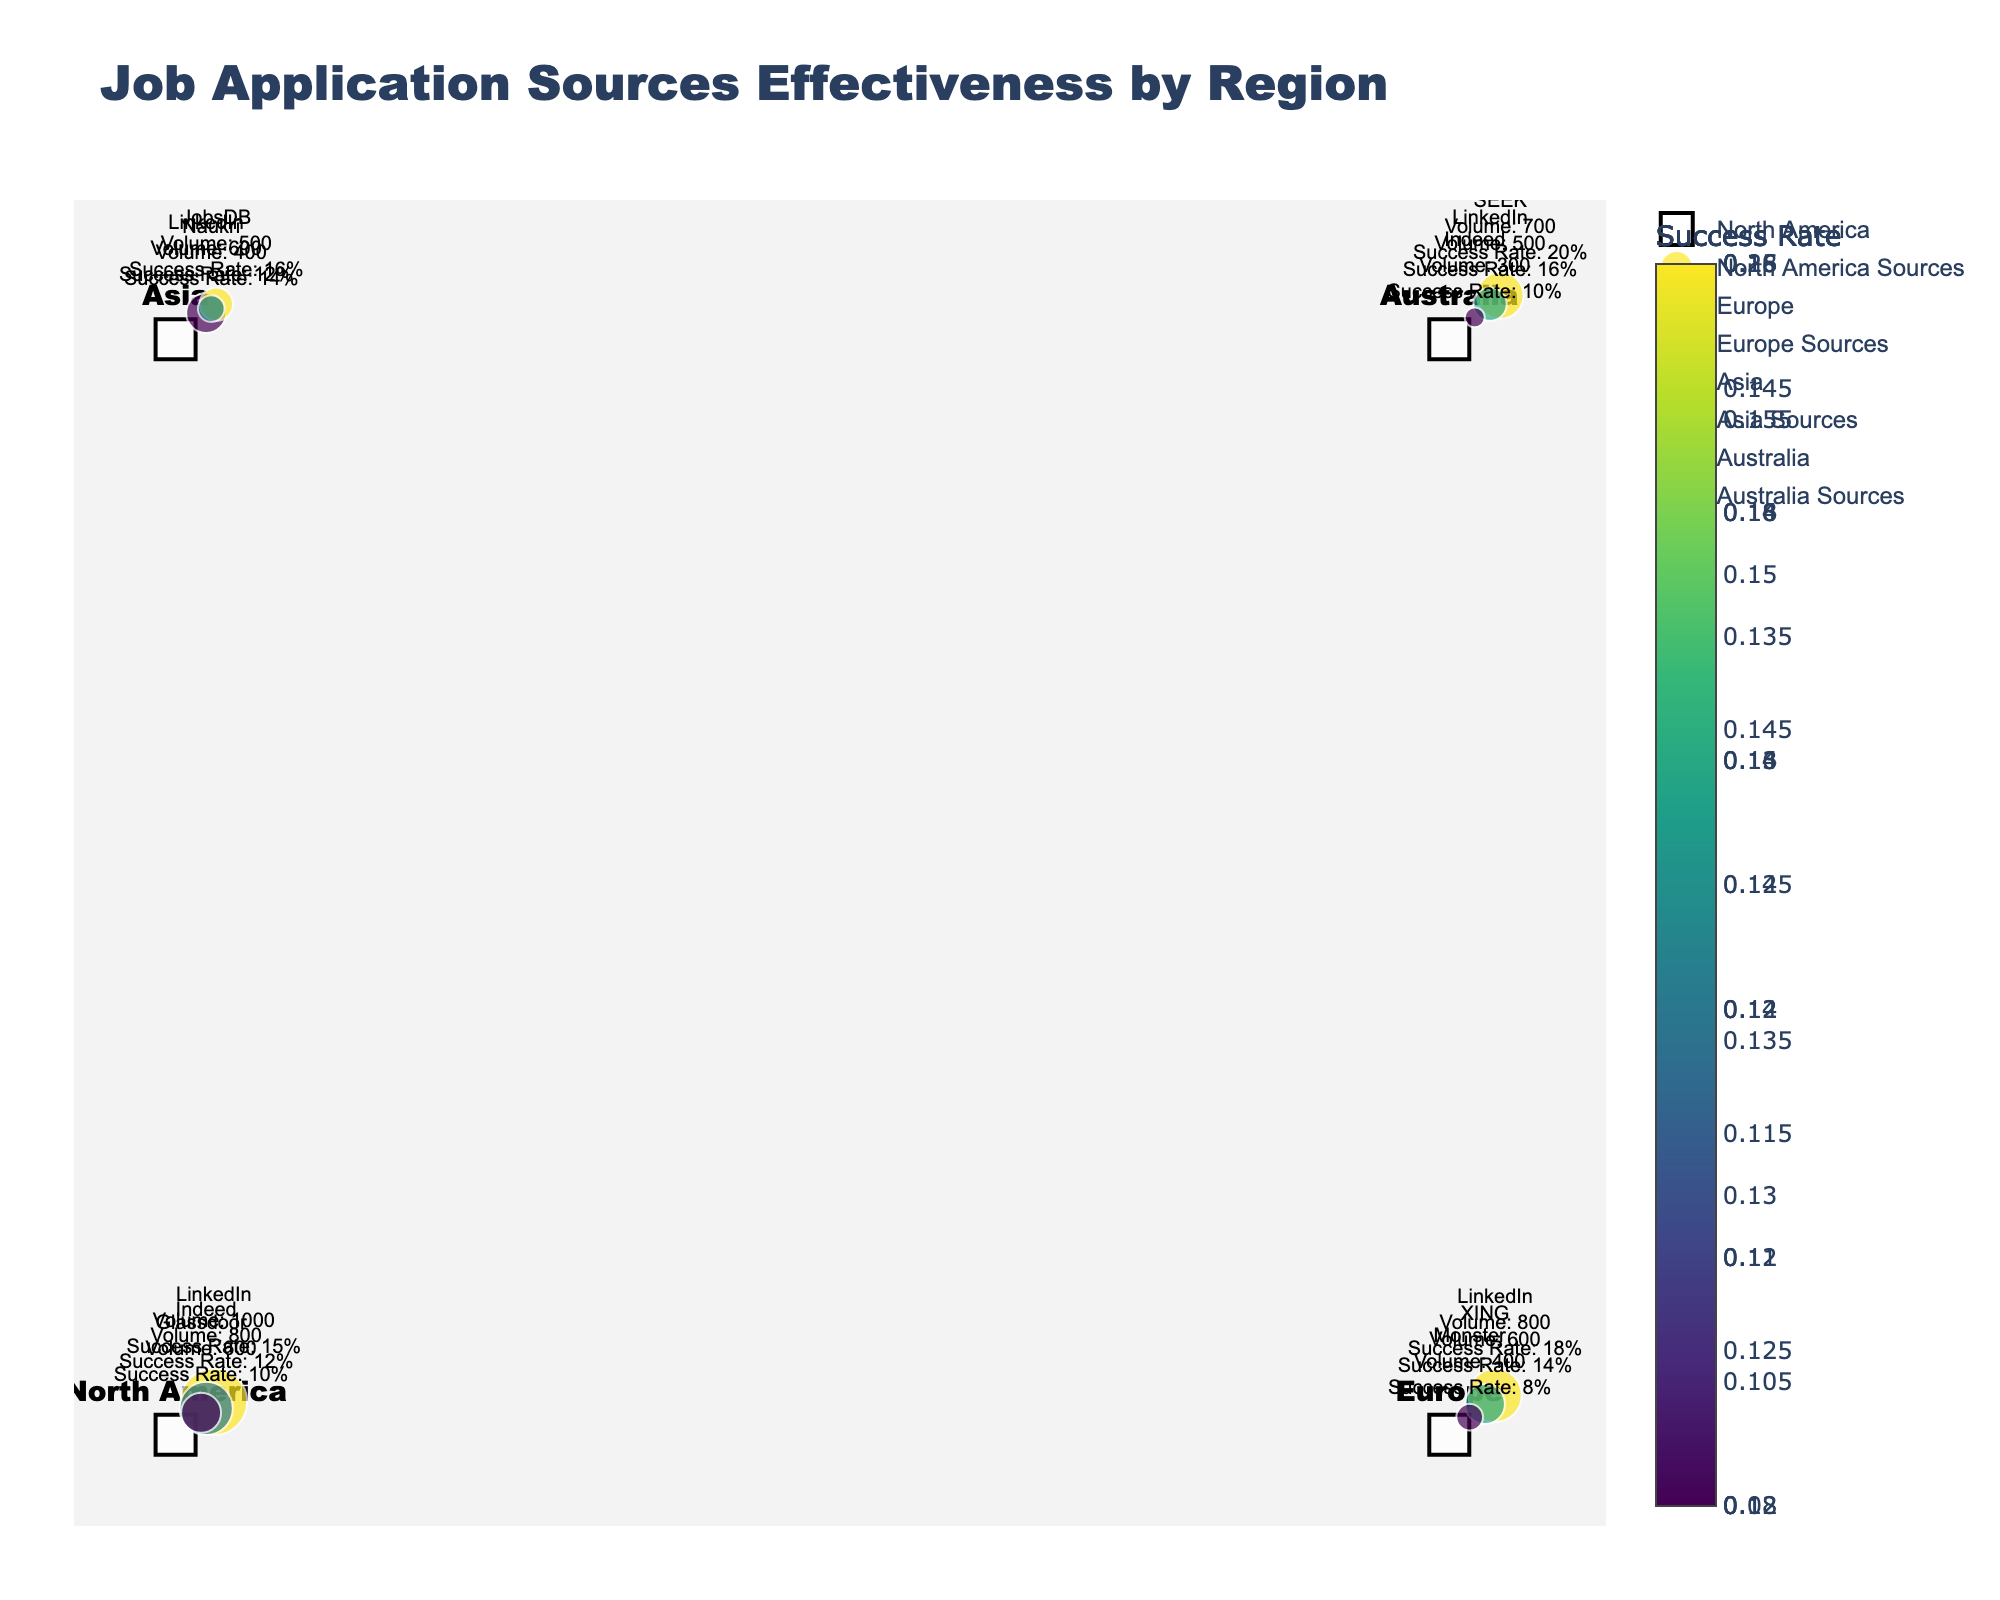What is the title of the figure? The title is typically found at the top of the figure. In this case, it states: "Job Application Sources Effectiveness by Region"
Answer: Job Application Sources Effectiveness by Region Which region has the job application source with the highest success rate? By looking at the color scale (where higher success rates are represented with brighter colors in Viridis), the source with the highest success rate is in the region where the SEEK source is located, which is Australia.
Answer: Australia How many job application sources are visualized for North America? North America is represented by a white square marker labeled with "North America". Observing the lines (or quivers) and text information originating from this region, we count three sources: LinkedIn, Indeed, and Glassdoor.
Answer: Three What is the job application source with the highest volume in Europe? By looking at the text annotations around the Europe marker, it is evident that LinkedIn has the highest volume, 800, compared to XING (600) and Monster (400).
Answer: LinkedIn What is the success rate for the source 'JobsDB' in Asia? The text annotation near the Asia marker lists 'JobsDB' and its associated success rate. The success rate displayed for JobsDB is 16%.
Answer: 16% Compare the success rates of LinkedIn in North America and Europe. Which one is higher? Looking at the text annotations near the North America and Europe markers, LinkedIn's success rate in North America is 15%, while in Europe it is 18%. Therefore, LinkedIn's success rate is higher in Europe.
Answer: Europe Which region has the least number of job application sources visualized, and how many sources are there? By counting the sources indicated by text annotations around each region marker (square), it can be seen that the fewest number of sources are in Europe, with three sources: LinkedIn, XING, and Monster.
Answer: Europe, three What is the ratio of the volumes of Indeed sources between North America and Australia? The volume of Indeed in North America is 800, whereas in Australia it is 300. The ratio is calculated as 800/300 = 8/3 or approximately 2.67.
Answer: 2.67 Which application source has the second highest success rate in Asia, and what is the rate? In the Asia region, the sources listed are LinkedIn (12%), JobsDB (16%), and Naukri (14%). The second highest success rate is for Naukri, with a success rate of 14%.
Answer: Naukri, 14% Compare the total volume of job applications from all sources in Australia with that of Europe. Which region has more total volume? Summing up the volumes for Australia (SEEK: 700, LinkedIn: 500, Indeed: 300) results in 700+500+300 = 1500. For Europe (LinkedIn: 800, XING: 600, Monster: 400), it results in 800+600+400 = 1800. Europe has more total volume.
Answer: Europe 